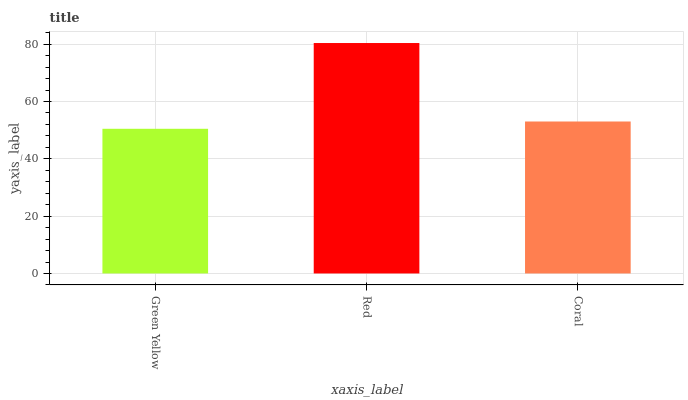Is Green Yellow the minimum?
Answer yes or no. Yes. Is Red the maximum?
Answer yes or no. Yes. Is Coral the minimum?
Answer yes or no. No. Is Coral the maximum?
Answer yes or no. No. Is Red greater than Coral?
Answer yes or no. Yes. Is Coral less than Red?
Answer yes or no. Yes. Is Coral greater than Red?
Answer yes or no. No. Is Red less than Coral?
Answer yes or no. No. Is Coral the high median?
Answer yes or no. Yes. Is Coral the low median?
Answer yes or no. Yes. Is Green Yellow the high median?
Answer yes or no. No. Is Red the low median?
Answer yes or no. No. 